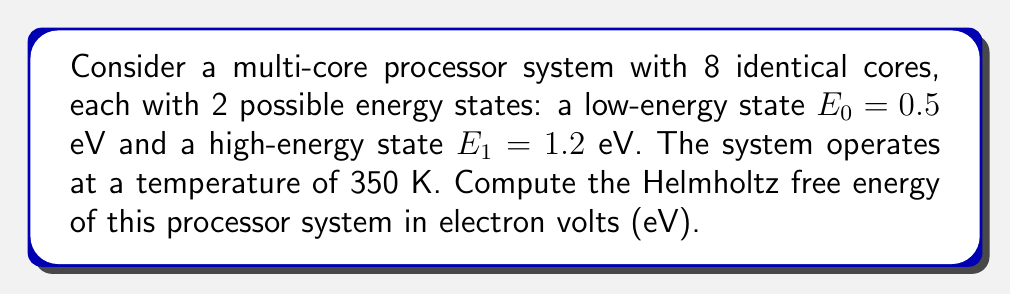Teach me how to tackle this problem. To compute the Helmholtz free energy of the multi-core processor system, we'll follow these steps:

1) First, recall the formula for Helmholtz free energy:
   $$F = -k_B T \ln Z$$
   where $k_B$ is Boltzmann's constant, $T$ is temperature, and $Z$ is the partition function.

2) For a system of 8 independent cores, the total partition function is the product of individual partition functions:
   $$Z = (z_1)^8$$
   where $z_1$ is the partition function for a single core.

3) For each core with two energy states, the partition function is:
   $$z_1 = e^{-\beta E_0} + e^{-\beta E_1}$$
   where $\beta = \frac{1}{k_B T}$

4) Calculate $\beta$:
   $$\beta = \frac{1}{k_B T} = \frac{1}{(8.617 \times 10^{-5} \text{ eV/K})(350 \text{ K})} = 33.17 \text{ eV}^{-1}$$

5) Calculate $z_1$:
   $$z_1 = e^{-33.17 \times 0.5} + e^{-33.17 \times 1.2} = 1.778 \times 10^{-8} + 5.955 \times 10^{-18} \approx 1.778 \times 10^{-8}$$

6) Calculate $Z$:
   $$Z = (1.778 \times 10^{-8})^8 = 5.691 \times 10^{-64}$$

7) Finally, calculate the Helmholtz free energy:
   $$\begin{align}
   F &= -k_B T \ln Z \\
   &= -(8.617 \times 10^{-5} \text{ eV/K})(350 \text{ K}) \ln(5.691 \times 10^{-64}) \\
   &= -0.03016 \text{ eV} \times (-146.53) \\
   &= 4.419 \text{ eV}
   \end{align}$$
Answer: 4.419 eV 